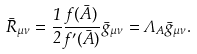<formula> <loc_0><loc_0><loc_500><loc_500>\bar { R } _ { \mu \nu } = \frac { 1 } { 2 } \frac { f ( \bar { A } ) } { f ^ { \prime } ( \bar { A } ) } \bar { g } _ { \mu \nu } = \Lambda _ { A } \bar { g } _ { \mu \nu } .</formula> 